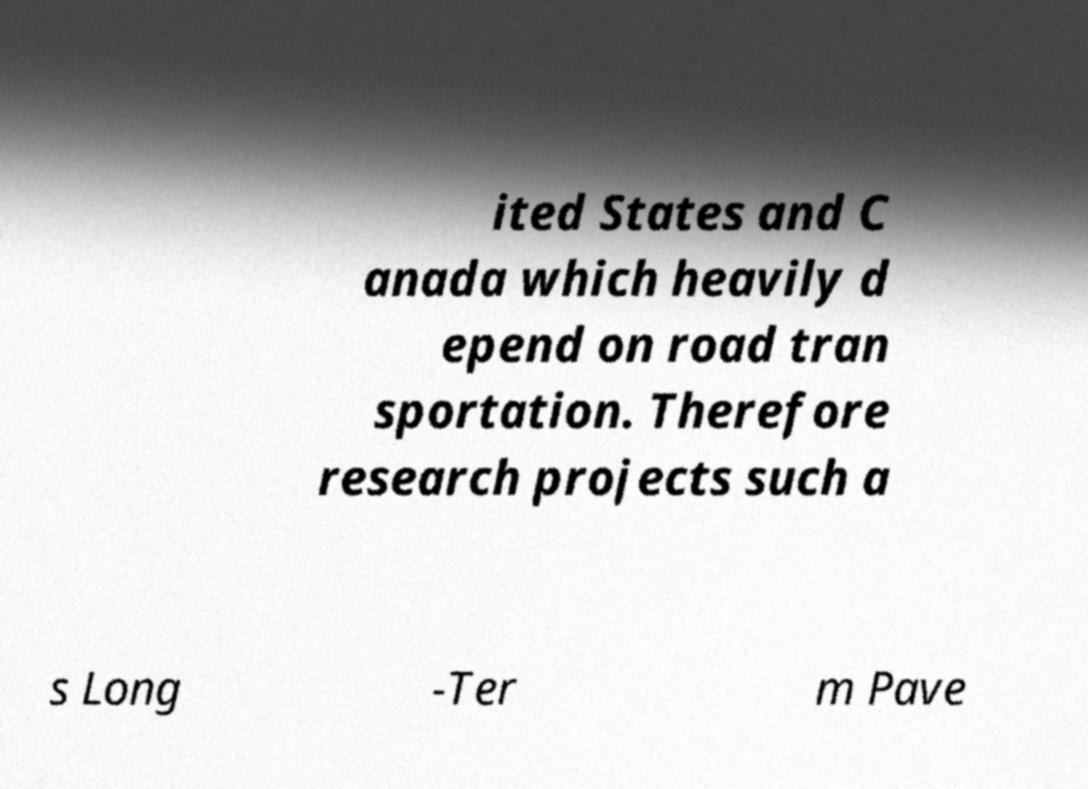Please identify and transcribe the text found in this image. ited States and C anada which heavily d epend on road tran sportation. Therefore research projects such a s Long -Ter m Pave 